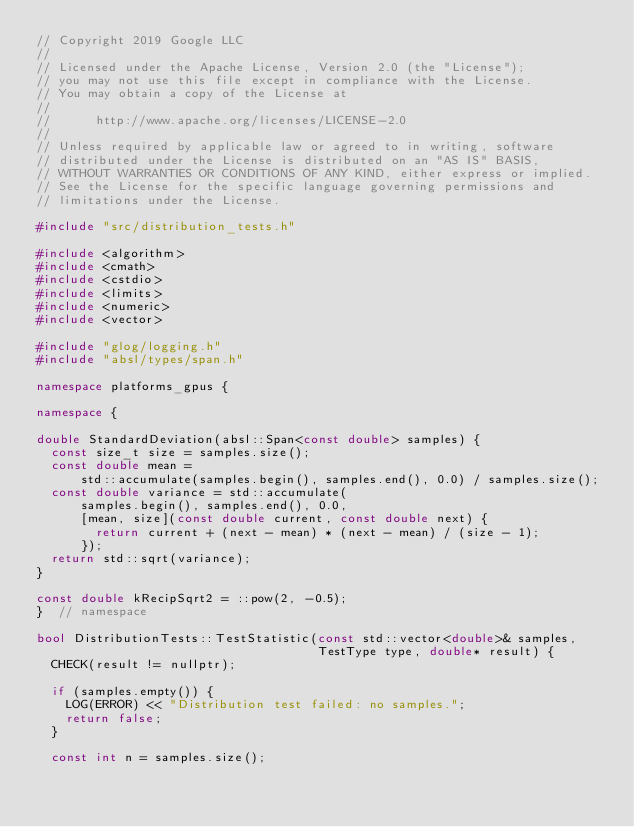<code> <loc_0><loc_0><loc_500><loc_500><_C++_>// Copyright 2019 Google LLC
//
// Licensed under the Apache License, Version 2.0 (the "License");
// you may not use this file except in compliance with the License.
// You may obtain a copy of the License at
//
//      http://www.apache.org/licenses/LICENSE-2.0
//
// Unless required by applicable law or agreed to in writing, software
// distributed under the License is distributed on an "AS IS" BASIS,
// WITHOUT WARRANTIES OR CONDITIONS OF ANY KIND, either express or implied.
// See the License for the specific language governing permissions and
// limitations under the License.

#include "src/distribution_tests.h"

#include <algorithm>
#include <cmath>
#include <cstdio>
#include <limits>
#include <numeric>
#include <vector>

#include "glog/logging.h"
#include "absl/types/span.h"

namespace platforms_gpus {

namespace {

double StandardDeviation(absl::Span<const double> samples) {
  const size_t size = samples.size();
  const double mean =
      std::accumulate(samples.begin(), samples.end(), 0.0) / samples.size();
  const double variance = std::accumulate(
      samples.begin(), samples.end(), 0.0,
      [mean, size](const double current, const double next) {
        return current + (next - mean) * (next - mean) / (size - 1);
      });
  return std::sqrt(variance);
}

const double kRecipSqrt2 = ::pow(2, -0.5);
}  // namespace

bool DistributionTests::TestStatistic(const std::vector<double>& samples,
                                      TestType type, double* result) {
  CHECK(result != nullptr);

  if (samples.empty()) {
    LOG(ERROR) << "Distribution test failed: no samples.";
    return false;
  }

  const int n = samples.size();</code> 